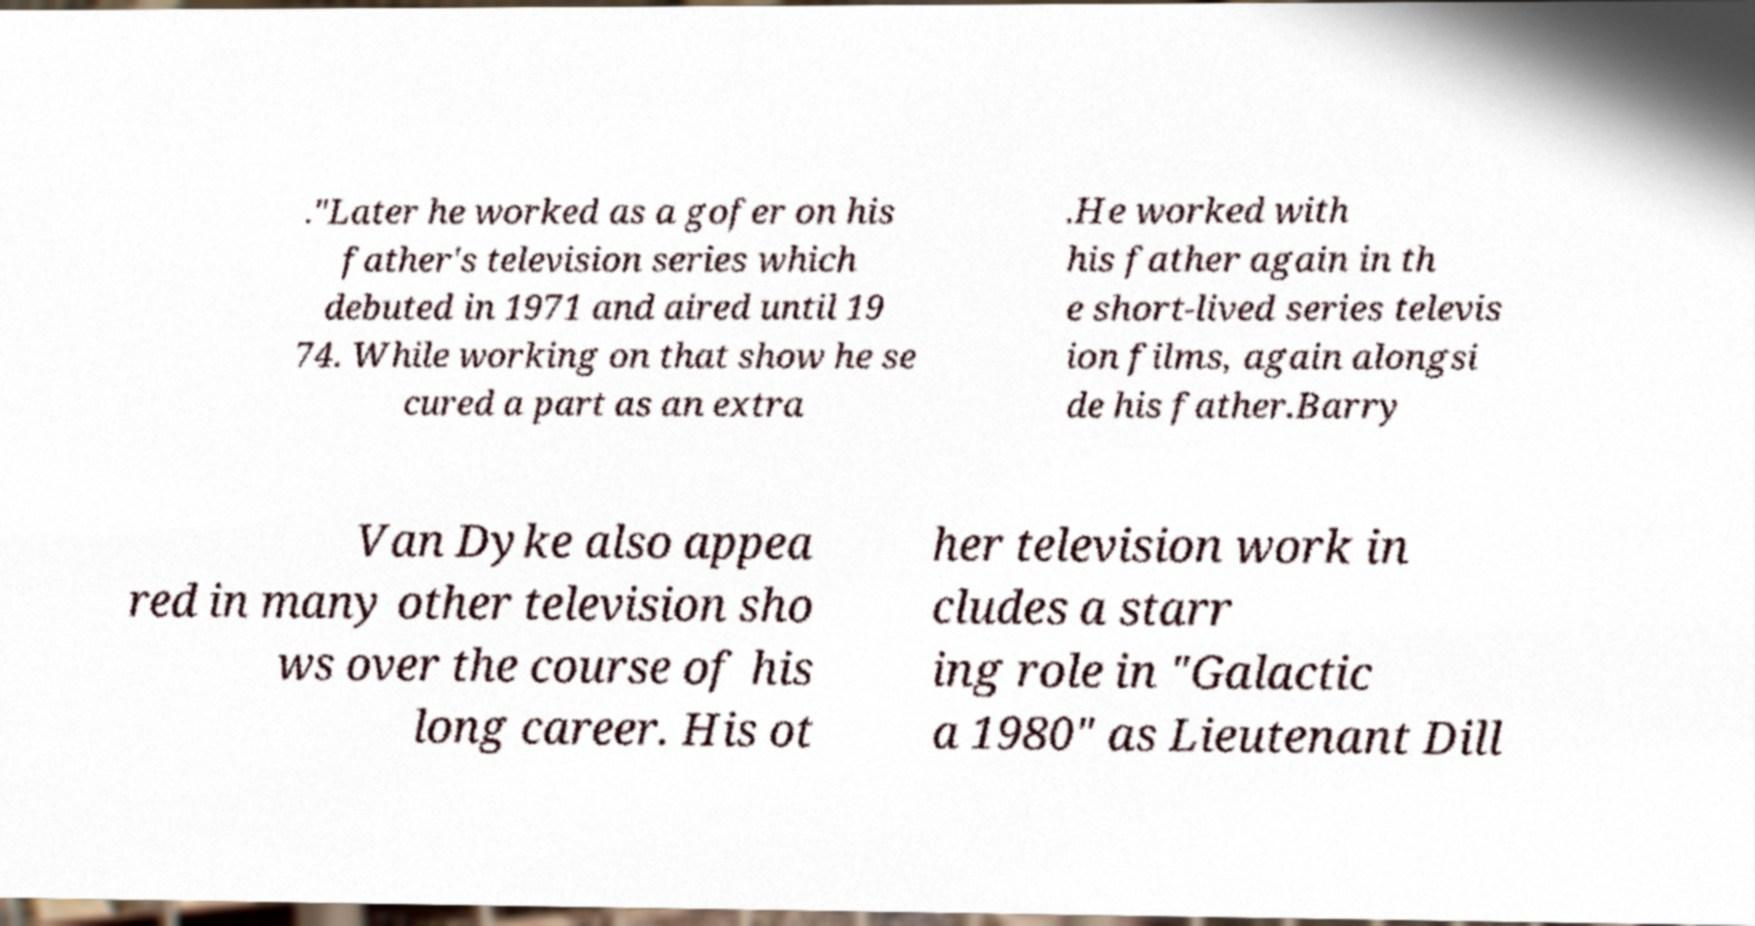Can you read and provide the text displayed in the image?This photo seems to have some interesting text. Can you extract and type it out for me? ."Later he worked as a gofer on his father's television series which debuted in 1971 and aired until 19 74. While working on that show he se cured a part as an extra .He worked with his father again in th e short-lived series televis ion films, again alongsi de his father.Barry Van Dyke also appea red in many other television sho ws over the course of his long career. His ot her television work in cludes a starr ing role in "Galactic a 1980" as Lieutenant Dill 